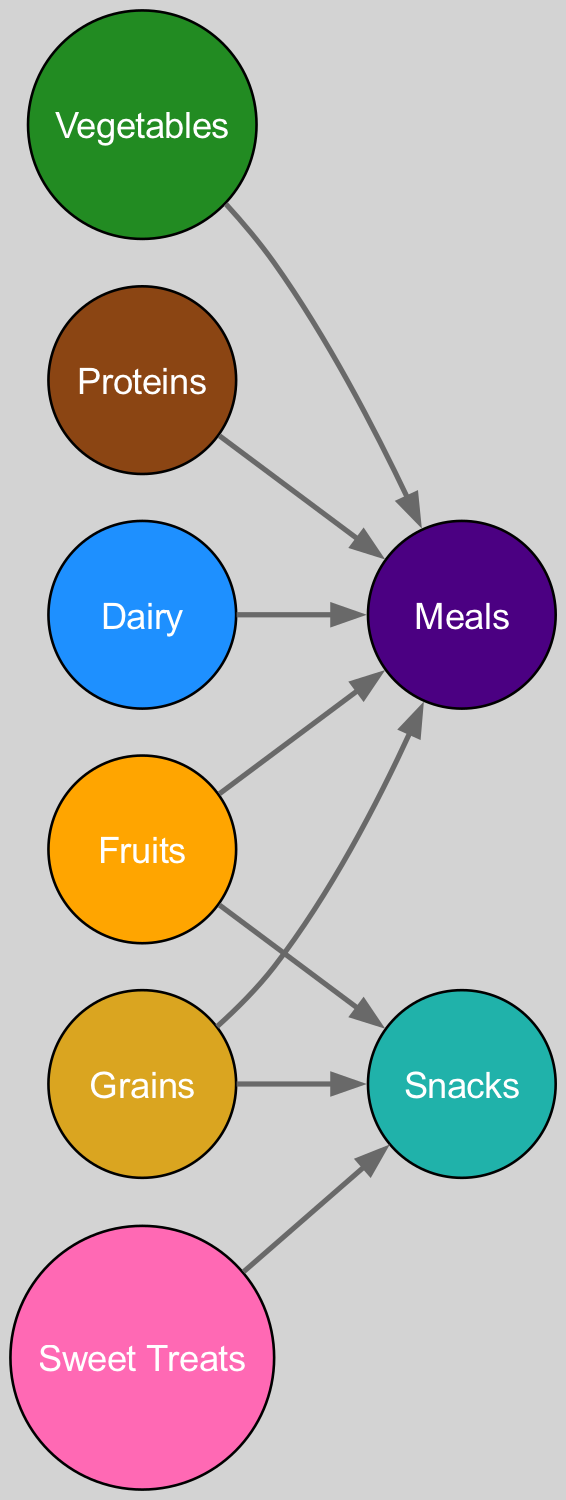What food group leads to Snacks? The directed graph shows an arrow pointing from the Fruits node to the Snacks node, indicating that Fruits contributes to Snacks.
Answer: Fruits How many nodes are there in the diagram? Counting all the nodes in the diagram, we find 8 distinct groups including Fruits, Vegetables, Grains, Proteins, Dairy, Sweet Treats, Meals, and Snacks.
Answer: 8 Which food group has connections to Meals? The directed graph indicates arrows pointing from Vegetables, Grains, Proteins, Dairy, and Fruits to the Meals node, showing these food groups contribute to Meals.
Answer: Vegetables, Grains, Proteins, Dairy, Fruits What is the relationship between Sweet Treats and Snacks? There is a directed edge from Sweet Treats to Snacks, which means Sweet Treats can contribute to the Snacks category.
Answer: Contributes to How many edges are directed towards Meals? Analyzing the edges in the diagram, there are 5 edges pointing directly to the Meals node from the respective food groups: Vegetables, Grains, Proteins, Dairy, and Fruits.
Answer: 5 Which food group has the most connections in the diagram? Grains have connections to both Meals and Snacks, totaling to 2 edges, which is more than any other single food group in terms of direct connections.
Answer: Grains How many food groups lead to Snacks? Looking at the edges directed towards Snacks, we find there are 2 contributing food groups: Fruits and Sweet Treats, as well as Grains. Therefore, 3 total food groups lead to Snacks.
Answer: 3 Are all food groups connected directly to Meals? Upon examining the diagram, it is evident that the food groups Proteins, Vegetables, Grains, Dairy, and Fruits are directly connected to Meals, while Sweet Treats and Snacks are not, indicating not all food groups connect to Meals.
Answer: No 